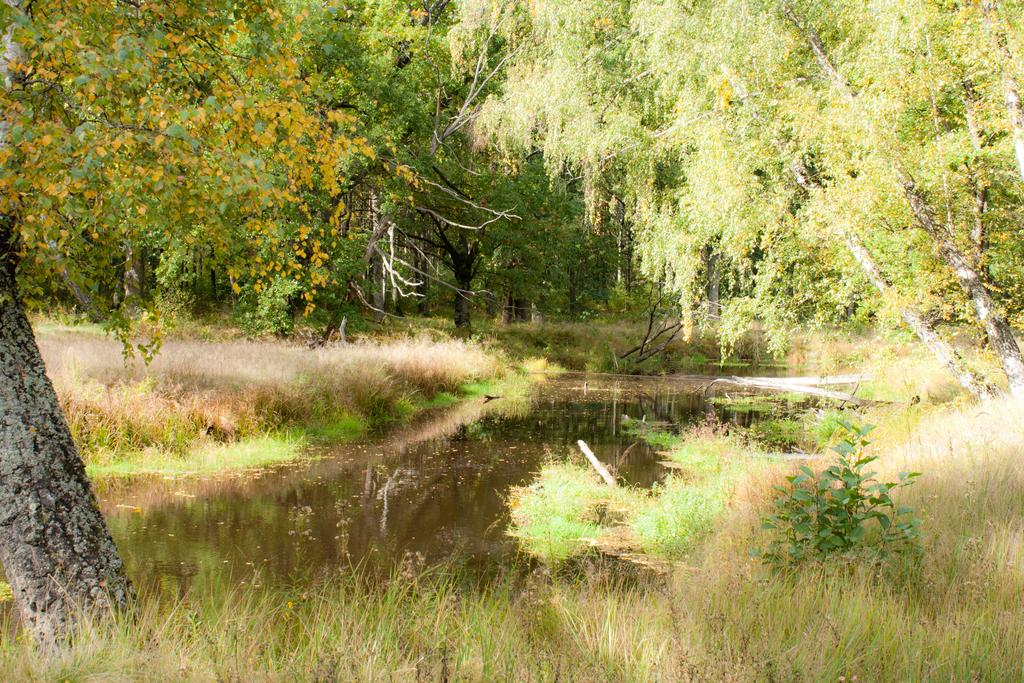What is the setting of the image? The image is an outside view. What can be seen in the middle of the image? There is a pond in the middle of the image. What surrounds the pond in the image? There are many plants around the pond. What is located on the left side of the image? There is a tree trunk on the left side of the image. What can be seen in the background of the image? There are many trees in the background of the image. What type of cushion is placed on the tree trunk in the image? There is no cushion present on the tree trunk in the image. What metal object can be seen floating in the pond? There is no metal object visible in the pond in the image. 